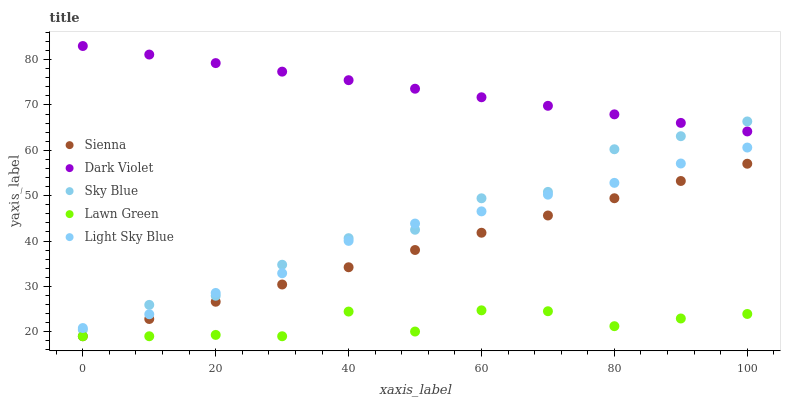Does Lawn Green have the minimum area under the curve?
Answer yes or no. Yes. Does Dark Violet have the maximum area under the curve?
Answer yes or no. Yes. Does Sky Blue have the minimum area under the curve?
Answer yes or no. No. Does Sky Blue have the maximum area under the curve?
Answer yes or no. No. Is Sienna the smoothest?
Answer yes or no. Yes. Is Lawn Green the roughest?
Answer yes or no. Yes. Is Sky Blue the smoothest?
Answer yes or no. No. Is Sky Blue the roughest?
Answer yes or no. No. Does Sienna have the lowest value?
Answer yes or no. Yes. Does Sky Blue have the lowest value?
Answer yes or no. No. Does Dark Violet have the highest value?
Answer yes or no. Yes. Does Sky Blue have the highest value?
Answer yes or no. No. Is Light Sky Blue less than Dark Violet?
Answer yes or no. Yes. Is Dark Violet greater than Sienna?
Answer yes or no. Yes. Does Dark Violet intersect Sky Blue?
Answer yes or no. Yes. Is Dark Violet less than Sky Blue?
Answer yes or no. No. Is Dark Violet greater than Sky Blue?
Answer yes or no. No. Does Light Sky Blue intersect Dark Violet?
Answer yes or no. No. 